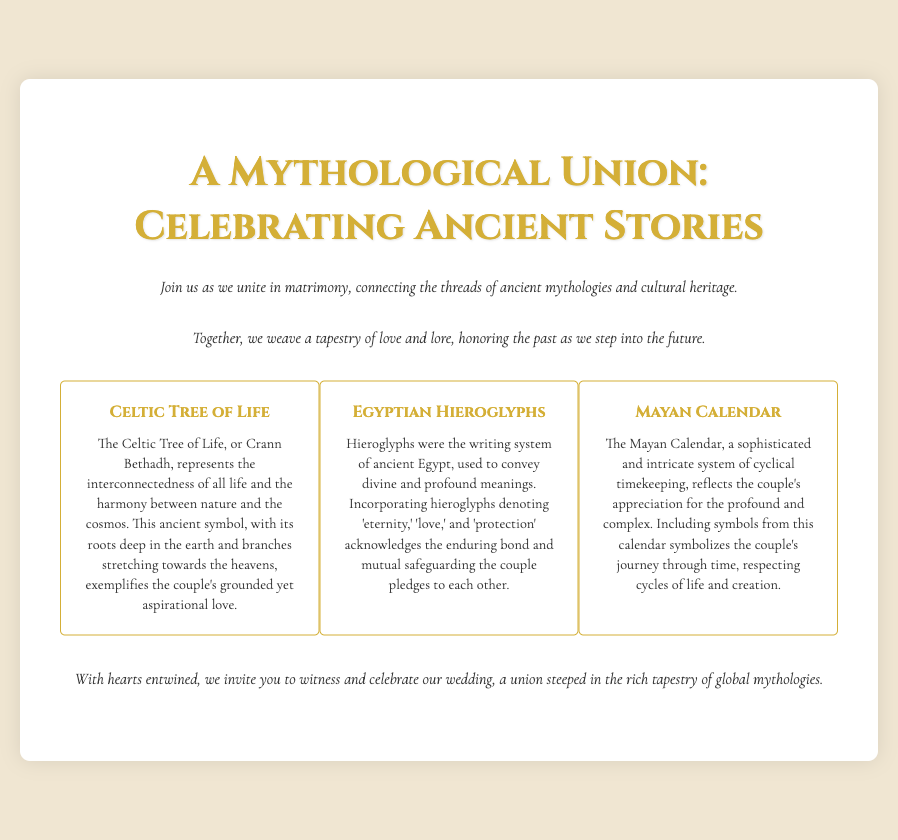What is the title of the invitation? The title of the invitation is stated prominently at the top of the document.
Answer: A Mythological Union: Celebrating Ancient Stories What cultural symbol represents interconnectedness in the invitation? The invitation describes the Celtic Tree of Life as a symbol representing interconnectedness.
Answer: Celtic Tree of Life Which writing system is featured in the invitation? The document mentions Egyptian hieroglyphs as the ancient writing system used.
Answer: Egyptian hieroglyphs What does the Mayan Calendar symbolize in the context of the invitation? The invitation explains that the Mayan Calendar symbolizes the couple's journey through time.
Answer: Journey through time What is the main theme of the wedding invitation? The document outlines the overarching theme as connecting ancient mythologies and cultural heritage.
Answer: Love and lore What is the aim of including hieroglyphs in the design? The document states that hieroglyphs denote 'eternity,' 'love,' and 'protection' in the invitation.
Answer: Acknowledging enduring bond What elements are included in the invitation? The invitation highlights three specific cultural elements that are included in the design.
Answer: Celtic Tree of Life, Egyptian Hieroglyphs, Mayan Calendar What kind of event is the invitation for? The document clearly states that this invitation is for a wedding.
Answer: Wedding How does the couple view their love, according to the invitation? The invitation mentions that the couple's love exemplifies being grounded yet aspirational.
Answer: Grounded yet aspirational 